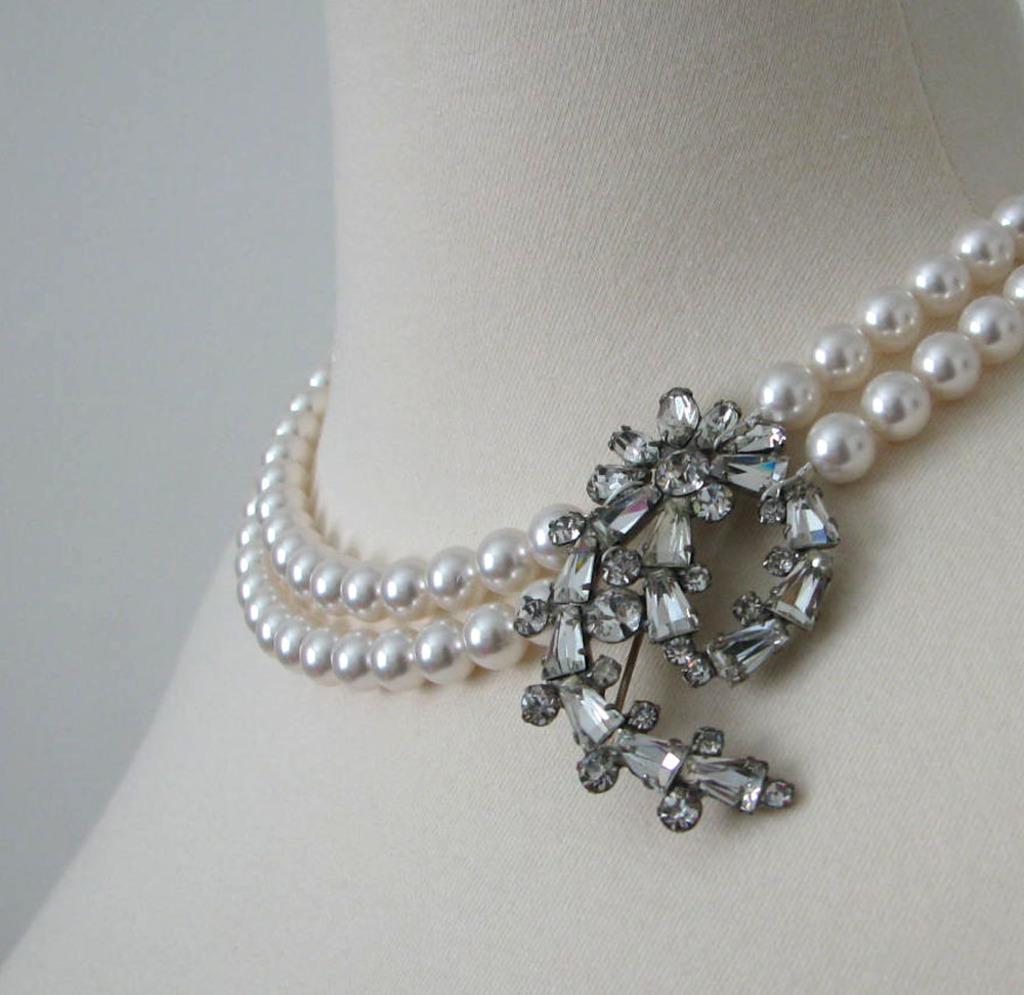Please provide a concise description of this image. In this picture there is an ornament. In the ornament there is a black pendant and there are white pearls. At the back there is a white background. 